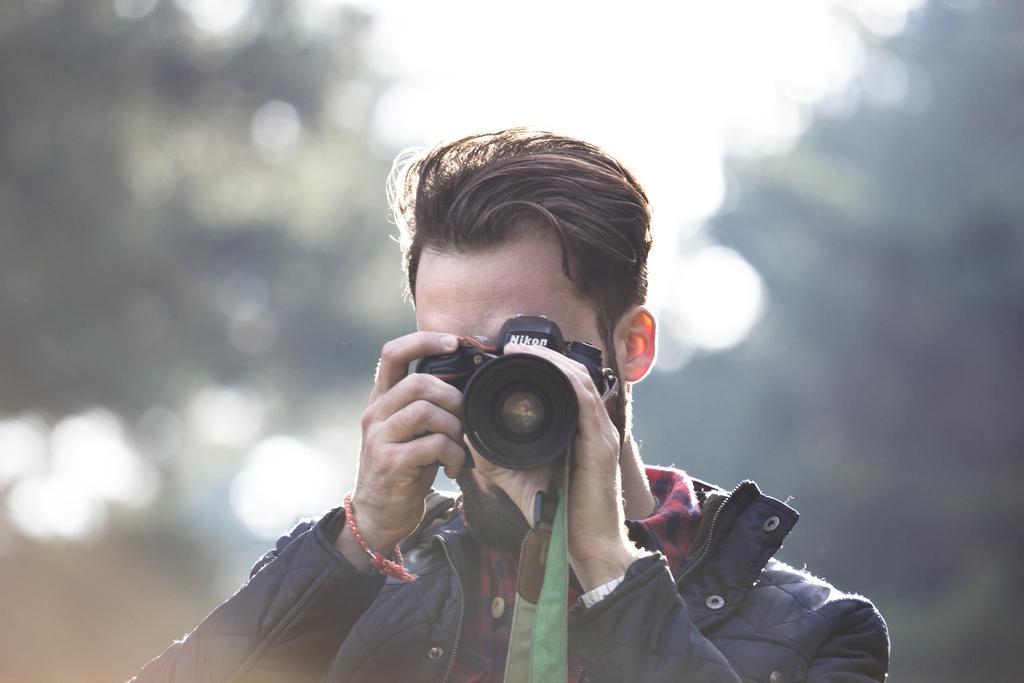Please provide a concise description of this image. This image is clicked outside. There is a man, who is holding a camera and clicking pictures. He is wearing a black color jacket. The background looks like it is edited and blurred. 